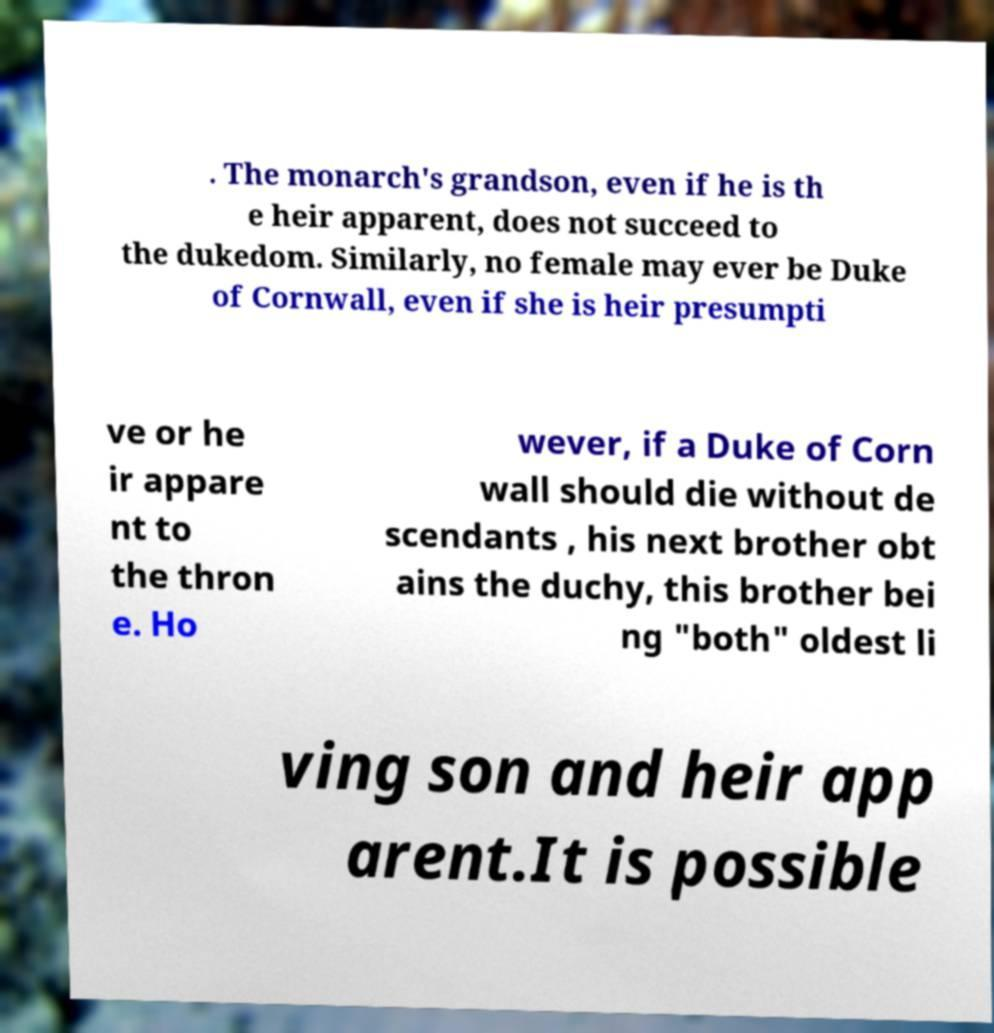Can you accurately transcribe the text from the provided image for me? . The monarch's grandson, even if he is th e heir apparent, does not succeed to the dukedom. Similarly, no female may ever be Duke of Cornwall, even if she is heir presumpti ve or he ir appare nt to the thron e. Ho wever, if a Duke of Corn wall should die without de scendants , his next brother obt ains the duchy, this brother bei ng "both" oldest li ving son and heir app arent.It is possible 